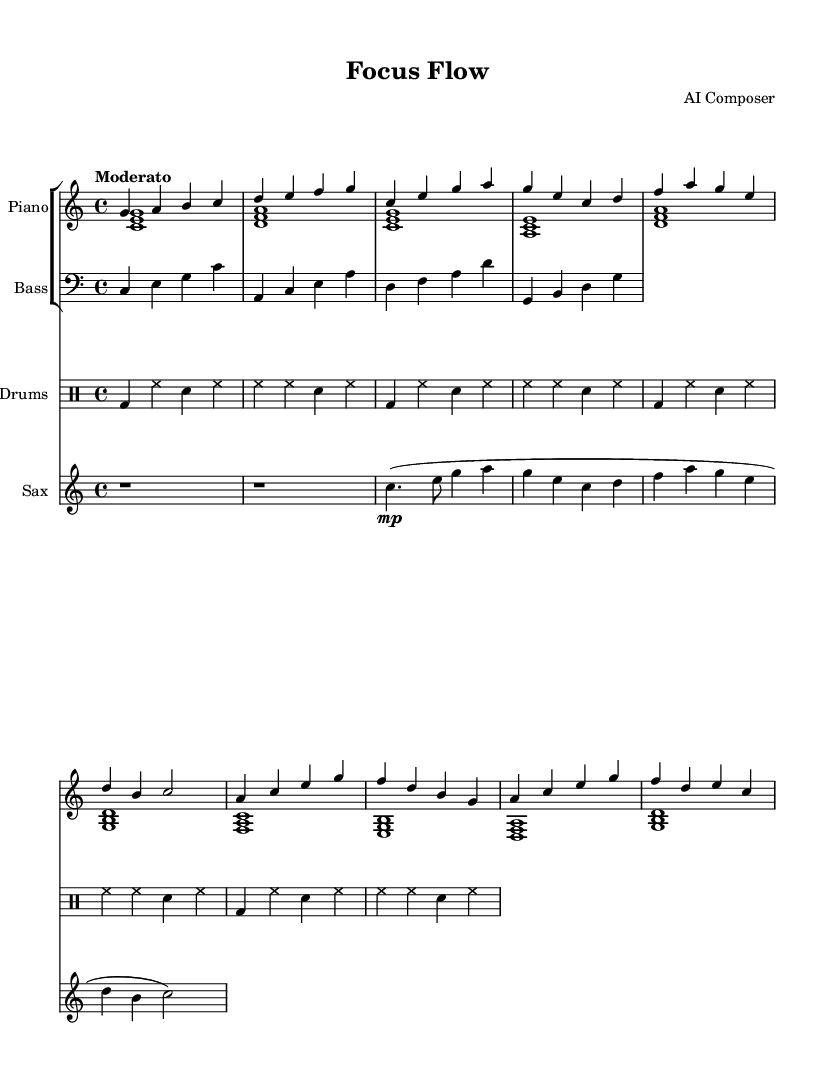What is the key signature of this music? The key signature is C major, which has no sharps or flats.
Answer: C major What is the time signature of this composition? The time signature is indicated at the beginning of the score, and it is 4/4.
Answer: 4/4 What is the tempo marking for this piece? The tempo marking is found near the beginning of the score, indicated as "Moderato."
Answer: Moderato How many measures do the piano parts contain? The piano parts can be counted by reviewing the measures in the staff; there are a total of 8 measures for the right hand and 8 for the left hand, totaling 8 measures as both parts share them.
Answer: 8 What is the instrument for the first part of the piece? The first part of the piece is labeled in the score, which identifies it as "Piano."
Answer: Piano Why is the saxophone resting for the first two measures? The saxophone has a rest symbol notated at the beginning of the score for the first two measures, indicating no sound is to be produced during that time.
Answer: Rest What type of music is this sheet music categorized as? The title "Focus Flow" and the instrumentation suggest it is categorized as jazz instrumental music, created to aid in focus and productivity.
Answer: Jazz instrumental 